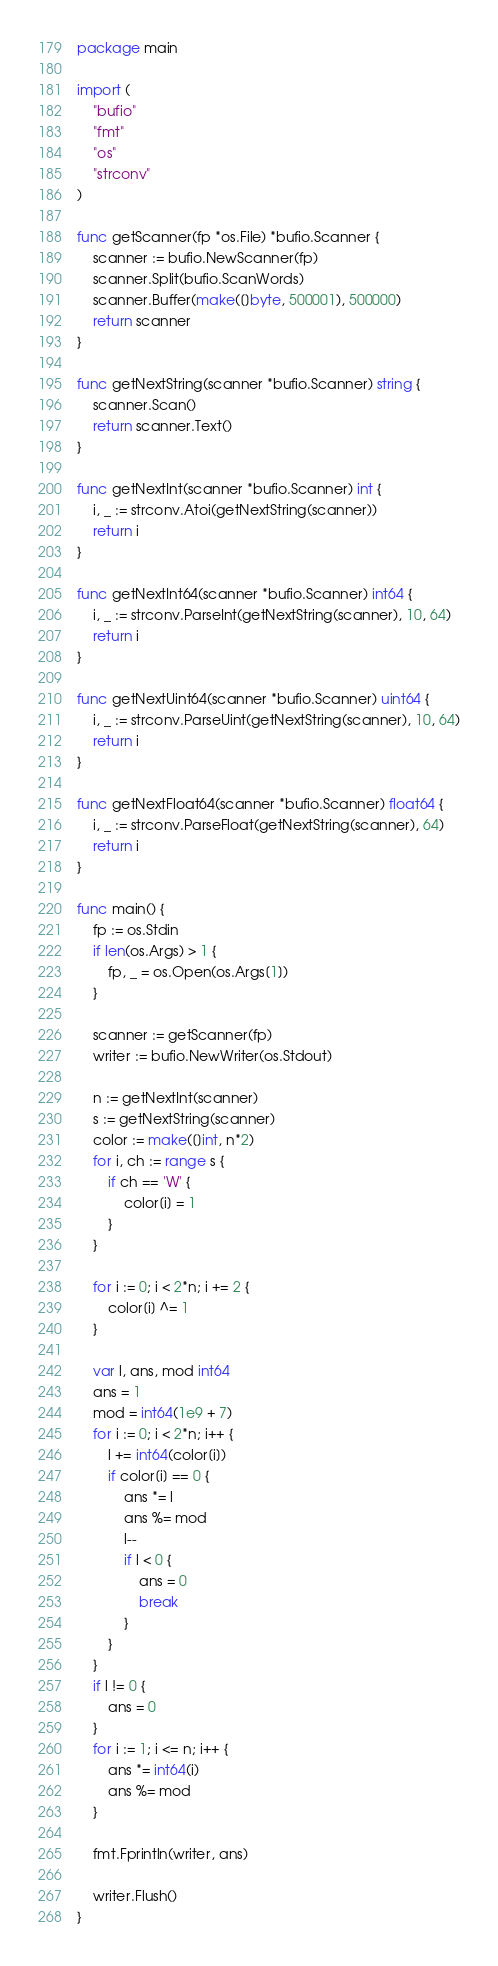<code> <loc_0><loc_0><loc_500><loc_500><_Go_>package main

import (
	"bufio"
	"fmt"
	"os"
	"strconv"
)

func getScanner(fp *os.File) *bufio.Scanner {
	scanner := bufio.NewScanner(fp)
	scanner.Split(bufio.ScanWords)
	scanner.Buffer(make([]byte, 500001), 500000)
	return scanner
}

func getNextString(scanner *bufio.Scanner) string {
	scanner.Scan()
	return scanner.Text()
}

func getNextInt(scanner *bufio.Scanner) int {
	i, _ := strconv.Atoi(getNextString(scanner))
	return i
}

func getNextInt64(scanner *bufio.Scanner) int64 {
	i, _ := strconv.ParseInt(getNextString(scanner), 10, 64)
	return i
}

func getNextUint64(scanner *bufio.Scanner) uint64 {
	i, _ := strconv.ParseUint(getNextString(scanner), 10, 64)
	return i
}

func getNextFloat64(scanner *bufio.Scanner) float64 {
	i, _ := strconv.ParseFloat(getNextString(scanner), 64)
	return i
}

func main() {
	fp := os.Stdin
	if len(os.Args) > 1 {
		fp, _ = os.Open(os.Args[1])
	}

	scanner := getScanner(fp)
	writer := bufio.NewWriter(os.Stdout)

	n := getNextInt(scanner)
	s := getNextString(scanner)
	color := make([]int, n*2)
	for i, ch := range s {
		if ch == 'W' {
			color[i] = 1
		}
	}

	for i := 0; i < 2*n; i += 2 {
		color[i] ^= 1
	}

	var l, ans, mod int64
	ans = 1
	mod = int64(1e9 + 7)
	for i := 0; i < 2*n; i++ {
		l += int64(color[i])
		if color[i] == 0 {
			ans *= l
			ans %= mod
			l--
			if l < 0 {
				ans = 0
				break
			}
		}
	}
	if l != 0 {
		ans = 0
	}
	for i := 1; i <= n; i++ {
		ans *= int64(i)
		ans %= mod
	}

	fmt.Fprintln(writer, ans)

	writer.Flush()
}
</code> 